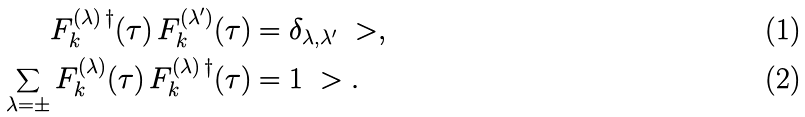<formula> <loc_0><loc_0><loc_500><loc_500>F _ { k } ^ { ( \lambda ) \, \dagger } ( \tau ) \, F _ { k } ^ { ( \lambda ^ { \prime } ) } ( \tau ) & = \delta _ { \lambda , \lambda ^ { \prime } } \ > , \\ \sum _ { \lambda = \pm } F _ { k } ^ { ( \lambda ) } ( \tau ) \, F _ { k } ^ { ( \lambda ) \, \dagger } ( \tau ) & = 1 \ > .</formula> 